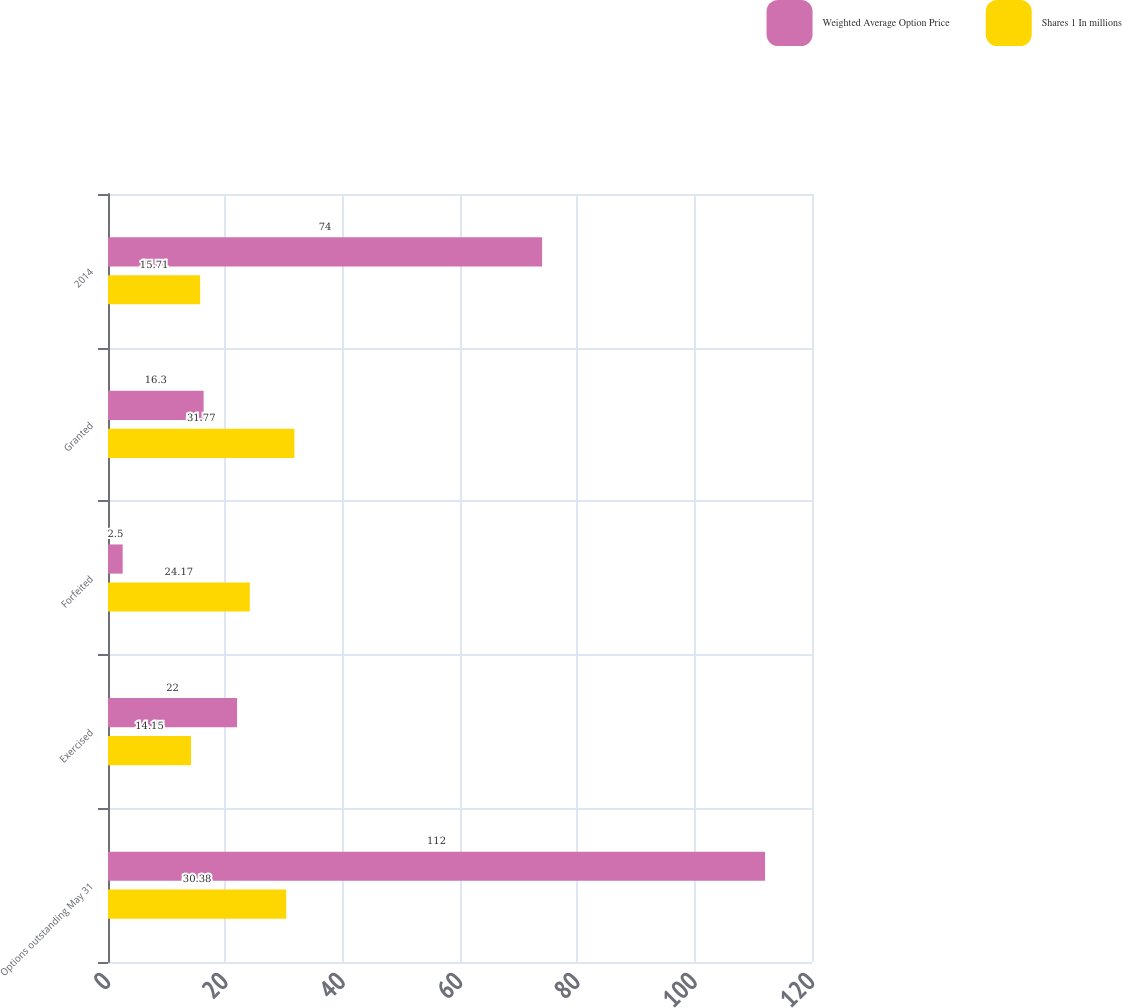Convert chart. <chart><loc_0><loc_0><loc_500><loc_500><stacked_bar_chart><ecel><fcel>Options outstanding May 31<fcel>Exercised<fcel>Forfeited<fcel>Granted<fcel>2014<nl><fcel>Weighted Average Option Price<fcel>112<fcel>22<fcel>2.5<fcel>16.3<fcel>74<nl><fcel>Shares 1 In millions<fcel>30.38<fcel>14.15<fcel>24.17<fcel>31.77<fcel>15.71<nl></chart> 